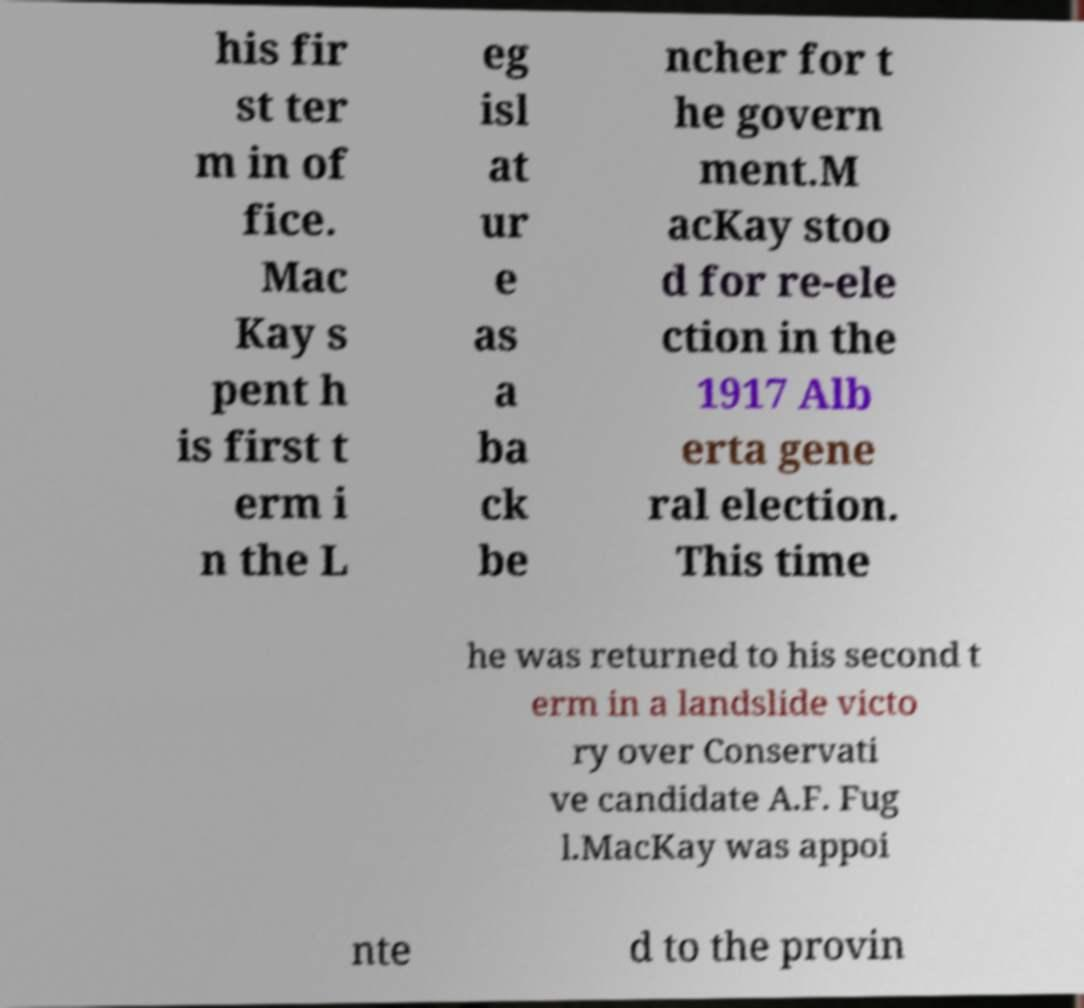Could you assist in decoding the text presented in this image and type it out clearly? his fir st ter m in of fice. Mac Kay s pent h is first t erm i n the L eg isl at ur e as a ba ck be ncher for t he govern ment.M acKay stoo d for re-ele ction in the 1917 Alb erta gene ral election. This time he was returned to his second t erm in a landslide victo ry over Conservati ve candidate A.F. Fug l.MacKay was appoi nte d to the provin 